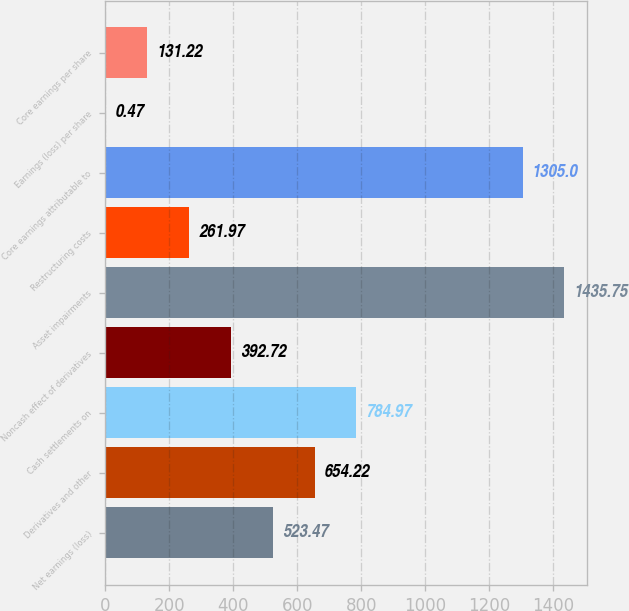<chart> <loc_0><loc_0><loc_500><loc_500><bar_chart><fcel>Net earnings (loss)<fcel>Derivatives and other<fcel>Cash settlements on<fcel>Noncash effect of derivatives<fcel>Asset impairments<fcel>Restructuring costs<fcel>Core earnings attributable to<fcel>Earnings (loss) per share<fcel>Core earnings per share<nl><fcel>523.47<fcel>654.22<fcel>784.97<fcel>392.72<fcel>1435.75<fcel>261.97<fcel>1305<fcel>0.47<fcel>131.22<nl></chart> 